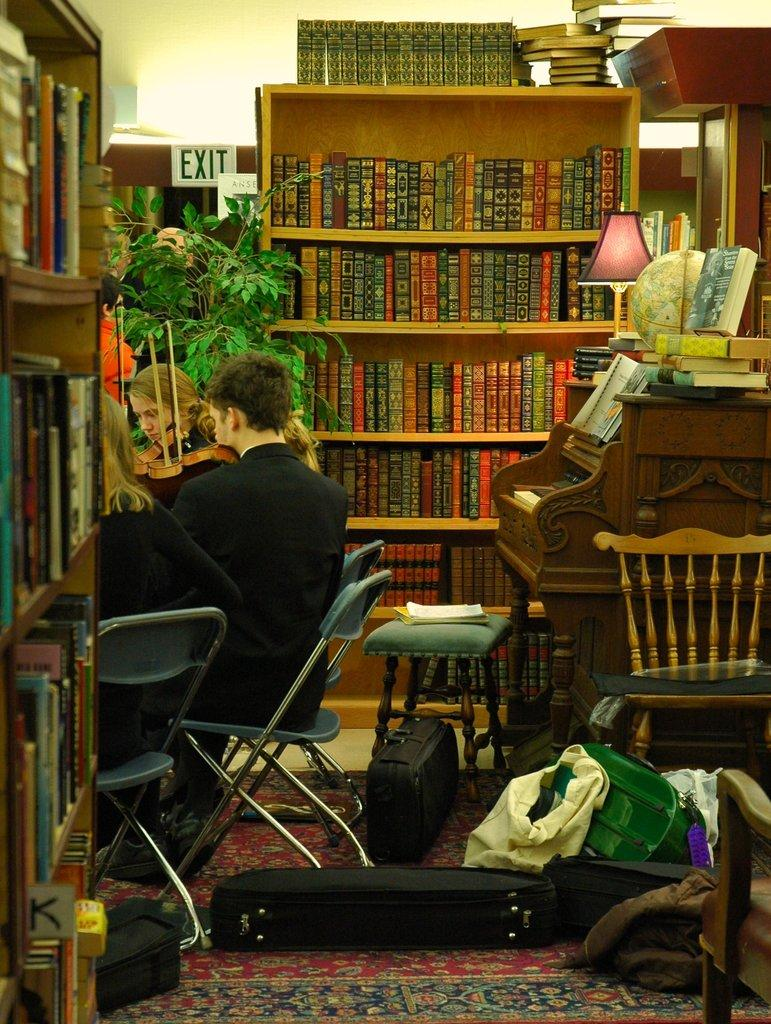How many people are present in the image? There are three people in the image. What are the people doing in the image? The people are sitting on a chair. What can be seen on the shelves in the image? There are two shelves filled with books in the image. What type of musical instrument is visible in the image? There is a wooden piano in the image. What object related to a musical instrument can be seen on the floor? There is a violin box on the floor in the image. What type of flesh can be seen in the image? There is no flesh visible in the image; it features people sitting on a chair, shelves with books, a wooden piano, and a violin box on the floor. 